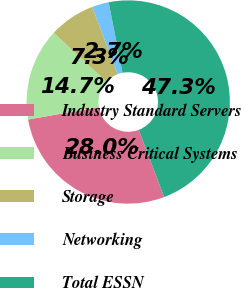Convert chart to OTSL. <chart><loc_0><loc_0><loc_500><loc_500><pie_chart><fcel>Industry Standard Servers<fcel>Business Critical Systems<fcel>Storage<fcel>Networking<fcel>Total ESSN<nl><fcel>28.0%<fcel>14.67%<fcel>7.33%<fcel>2.67%<fcel>47.33%<nl></chart> 